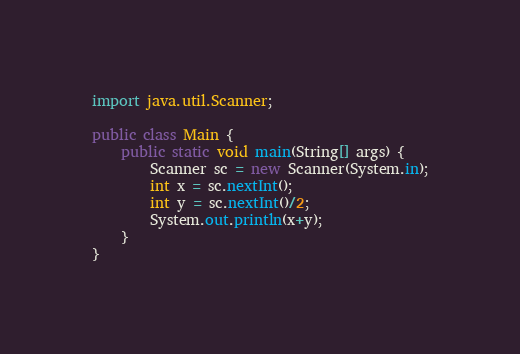Convert code to text. <code><loc_0><loc_0><loc_500><loc_500><_Java_>import java.util.Scanner;

public class Main {
	public static void main(String[] args) {
		Scanner sc = new Scanner(System.in);
		int x = sc.nextInt();
		int y = sc.nextInt()/2;
		System.out.println(x+y);
	}
}
</code> 